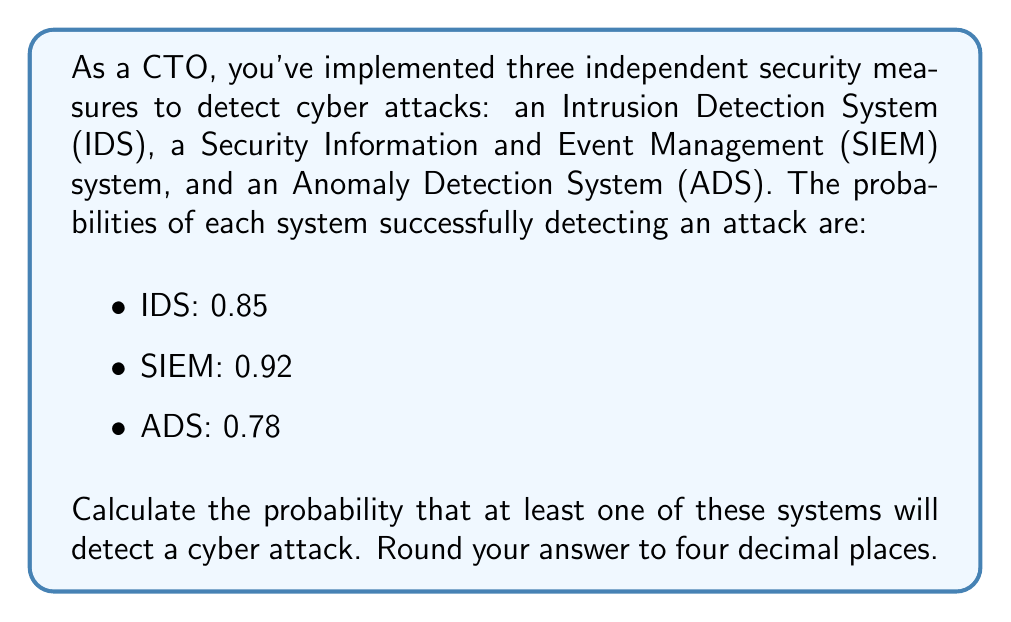Teach me how to tackle this problem. To solve this problem, we'll use the concept of probability of the complement event. Instead of calculating the probability of at least one system detecting the attack directly, we'll calculate the probability of all systems failing to detect the attack and then subtract that from 1.

Let's follow these steps:

1) First, calculate the probability of each system failing to detect the attack:
   
   P(IDS fails) = 1 - 0.85 = 0.15
   P(SIEM fails) = 1 - 0.92 = 0.08
   P(ADS fails) = 1 - 0.78 = 0.22

2) Since the systems are independent, the probability of all systems failing is the product of their individual failure probabilities:

   P(all fail) = P(IDS fails) × P(SIEM fails) × P(ADS fails)
               = 0.15 × 0.08 × 0.22

3) Calculate this probability:

   P(all fail) = 0.15 × 0.08 × 0.22 = 0.00264

4) The probability of at least one system detecting the attack is the complement of all systems failing:

   P(at least one detects) = 1 - P(all fail)
                           = 1 - 0.00264
                           = 0.99736

5) Rounding to four decimal places:

   P(at least one detects) ≈ 0.9974

Therefore, the probability that at least one of these systems will detect a cyber attack is approximately 0.9974 or 99.74%.
Answer: 0.9974 